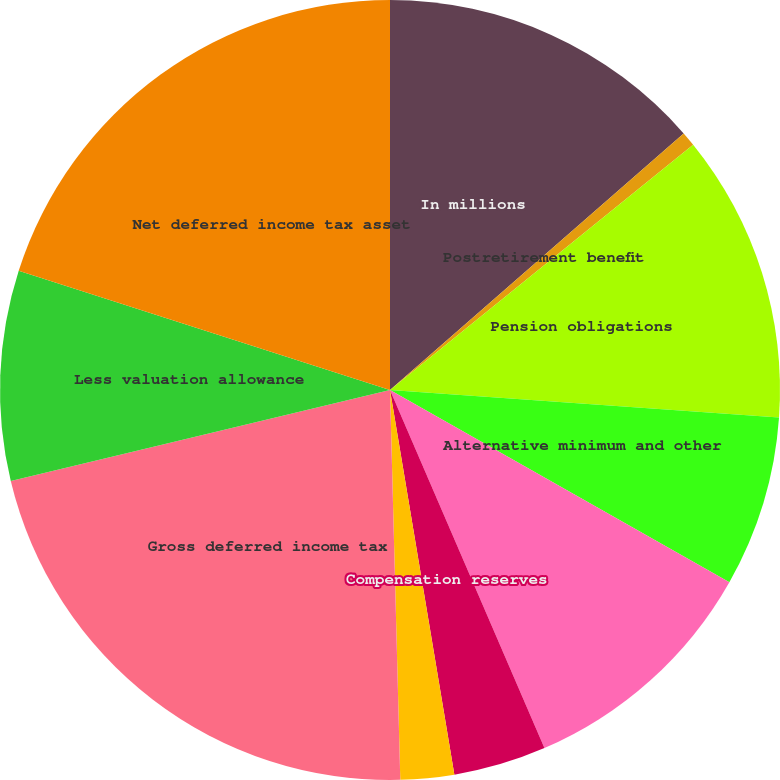Convert chart. <chart><loc_0><loc_0><loc_500><loc_500><pie_chart><fcel>In millions<fcel>Postretirement benefit<fcel>Pension obligations<fcel>Alternative minimum and other<fcel>Net operating and capital loss<fcel>Compensation reserves<fcel>Other<fcel>Gross deferred income tax<fcel>Less valuation allowance<fcel>Net deferred income tax asset<nl><fcel>13.57%<fcel>0.6%<fcel>11.95%<fcel>7.08%<fcel>10.32%<fcel>3.84%<fcel>2.22%<fcel>21.67%<fcel>8.7%<fcel>20.05%<nl></chart> 